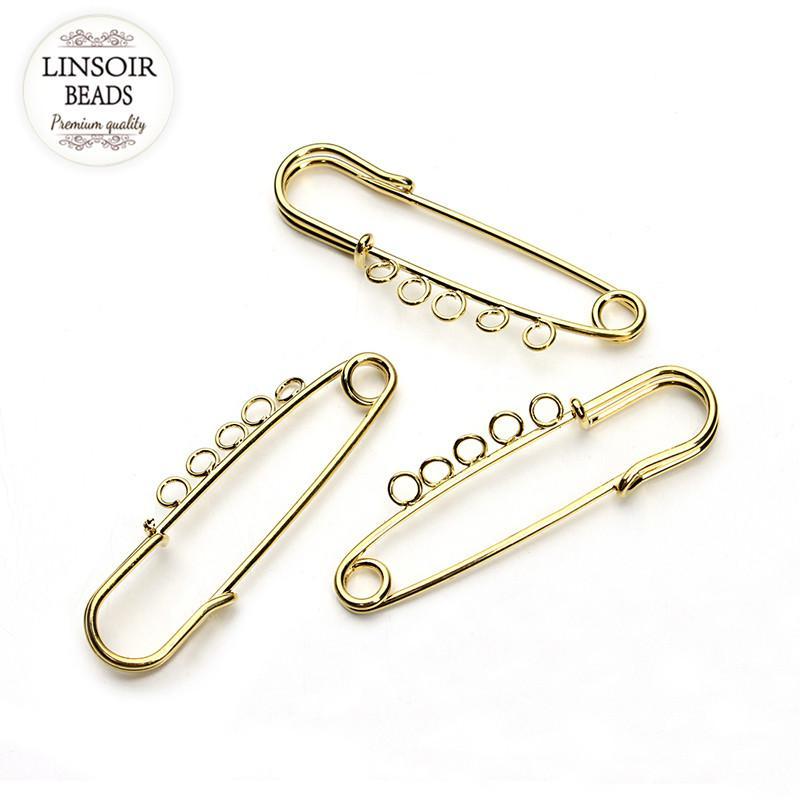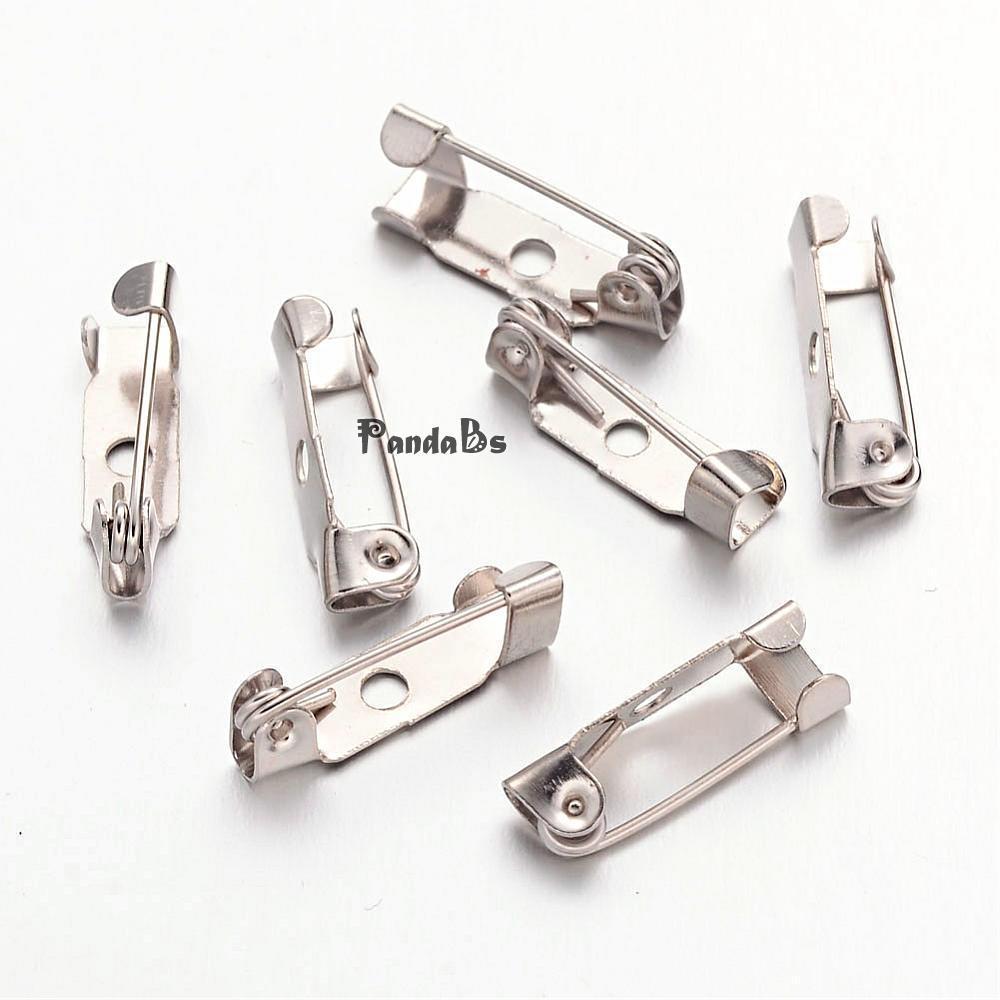The first image is the image on the left, the second image is the image on the right. For the images displayed, is the sentence "Most of the fasteners are gold." factually correct? Answer yes or no. No. 